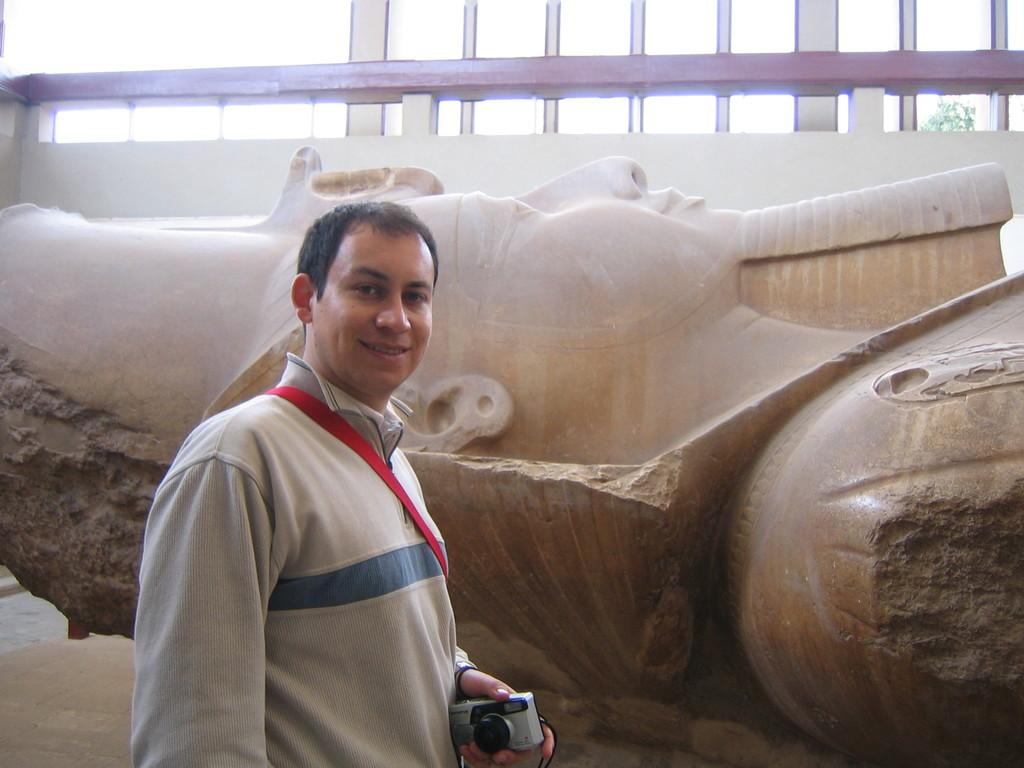What is the man in the image doing? The man is standing in the image and smiling. What is the man holding in his left hand? The man is holding a camera in his left hand. What can be seen behind the man in the image? There is a statue behind the man. What is the man's belief about the slip in the image? There is no slip present in the image, so it is not possible to determine the man's belief about it. 